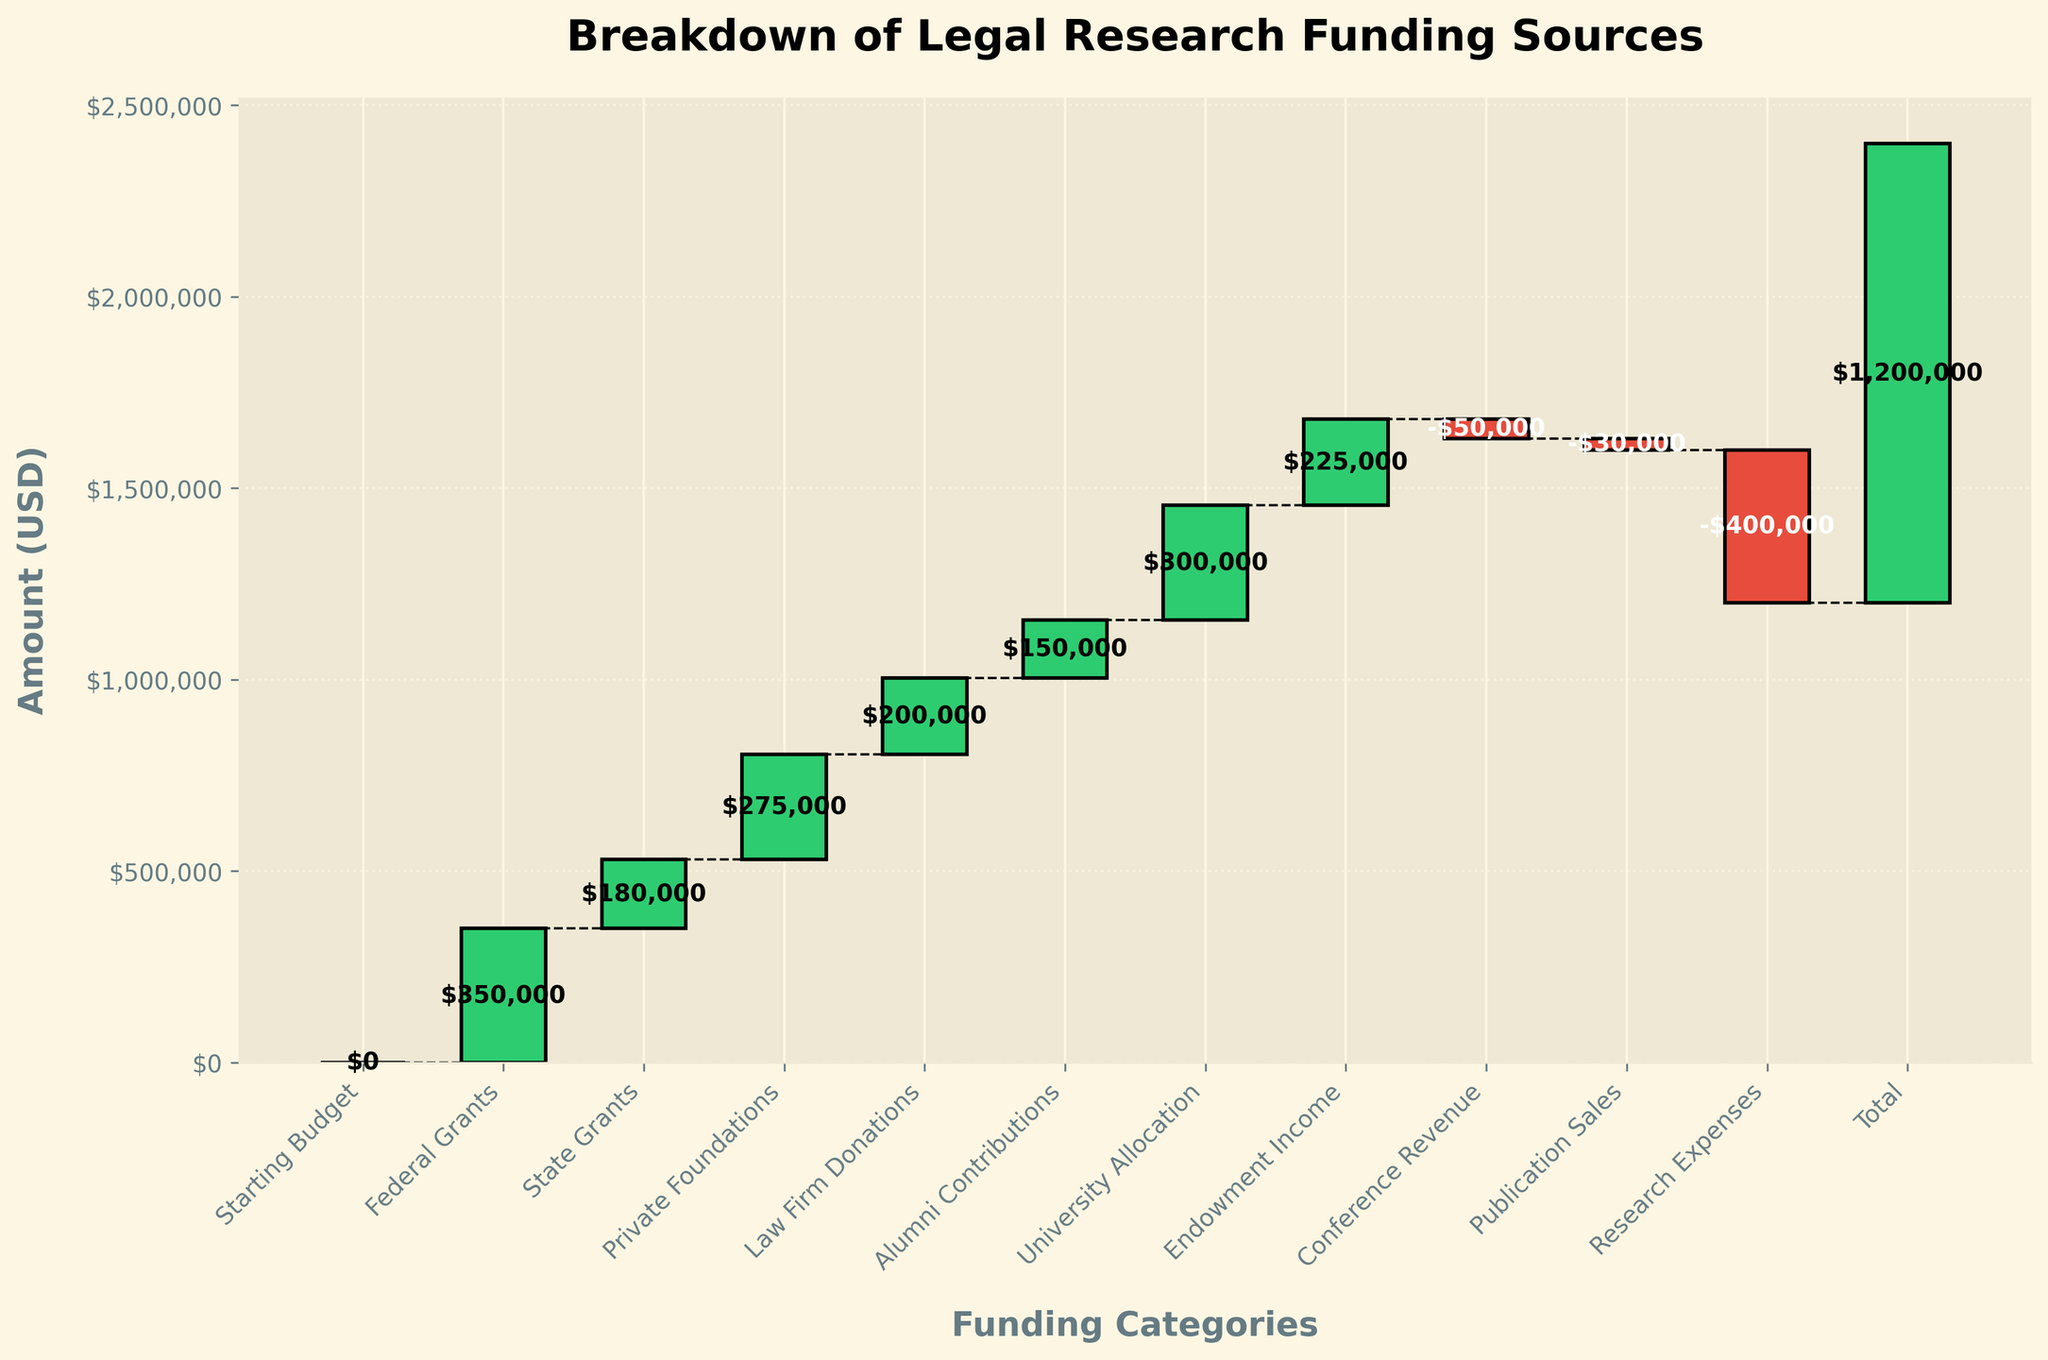What is the title of the figure? The title is usually found at the top of the figure and is meant to summarize the content or focus.
Answer: Breakdown of Legal Research Funding Sources How many funding categories are displayed in the figure? To find the number of funding categories, count the number of unique bars or labels along the x-axis.
Answer: 12 What color represents funding sources with positive values? Positive values are indicated by a specific color scheme, often denoted by lighter, warmer colors in the figure.
Answer: Green Which category contributes the most amount of funding? Identify the tallest bar or the bar with the highest value in the figure to see which category contributes the most.
Answer: University Allocation What is the cumulative funding amount after adding Federal Grants? The cumulative amount is calculated by summing the starting budget and the federal grants. Here, the starting budget is 0.
Answer: $350,000 What is the difference in funding between Federal Grants and State Grants? To find the difference, subtract the value of State Grants from Federal Grants. So, $350,000 - $180,000.
Answer: $170,000 How do Law Firm Donations compare to Private Foundations? To compare, look at the height of the bars or their values to see which is greater or smaller.
Answer: Private Foundations are higher What is the overall trend in the funding contributions from the starting budget to the total? Analyze the sequence of bars to understand if the overall trend is increasing, decreasing, or mixed.
Answer: Increasing What is the total combined amount from State Grants and Alumni Contributions? Sum the values from State Grants ($180,000) and Alumni Contributions ($150,000).
Answer: $330,000 How does the figure indicate the reduction in funding from Conference Revenue and Publication Sales? Negative contributions are often marked by a distinct color, usually darker or contrasting, and a downward direction in the bar.
Answer: Red bars 